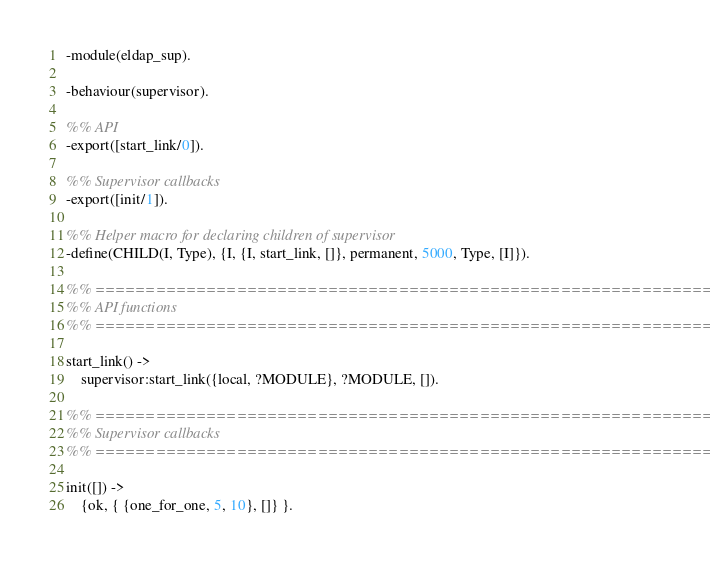<code> <loc_0><loc_0><loc_500><loc_500><_Erlang_>
-module(eldap_sup).

-behaviour(supervisor).

%% API
-export([start_link/0]).

%% Supervisor callbacks
-export([init/1]).

%% Helper macro for declaring children of supervisor
-define(CHILD(I, Type), {I, {I, start_link, []}, permanent, 5000, Type, [I]}).

%% ===================================================================
%% API functions
%% ===================================================================

start_link() ->
    supervisor:start_link({local, ?MODULE}, ?MODULE, []).

%% ===================================================================
%% Supervisor callbacks
%% ===================================================================

init([]) ->
    {ok, { {one_for_one, 5, 10}, []} }.

</code> 